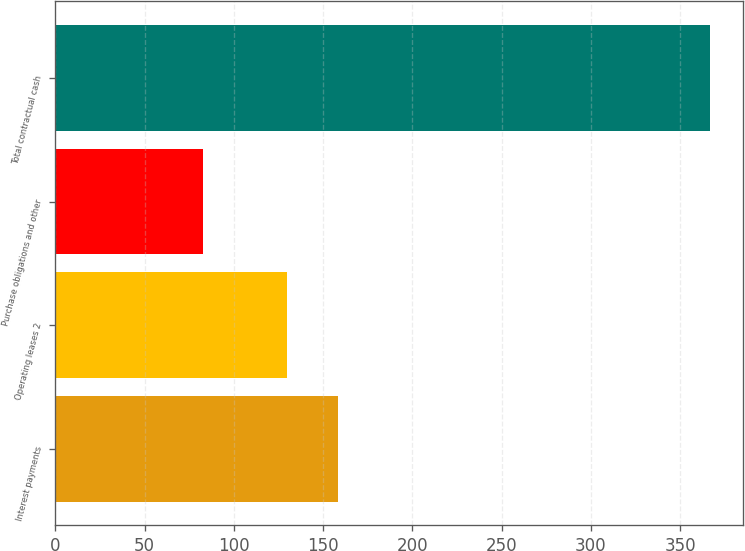Convert chart to OTSL. <chart><loc_0><loc_0><loc_500><loc_500><bar_chart><fcel>Interest payments<fcel>Operating leases 2<fcel>Purchase obligations and other<fcel>Total contractual cash<nl><fcel>158.4<fcel>130<fcel>83<fcel>367<nl></chart> 